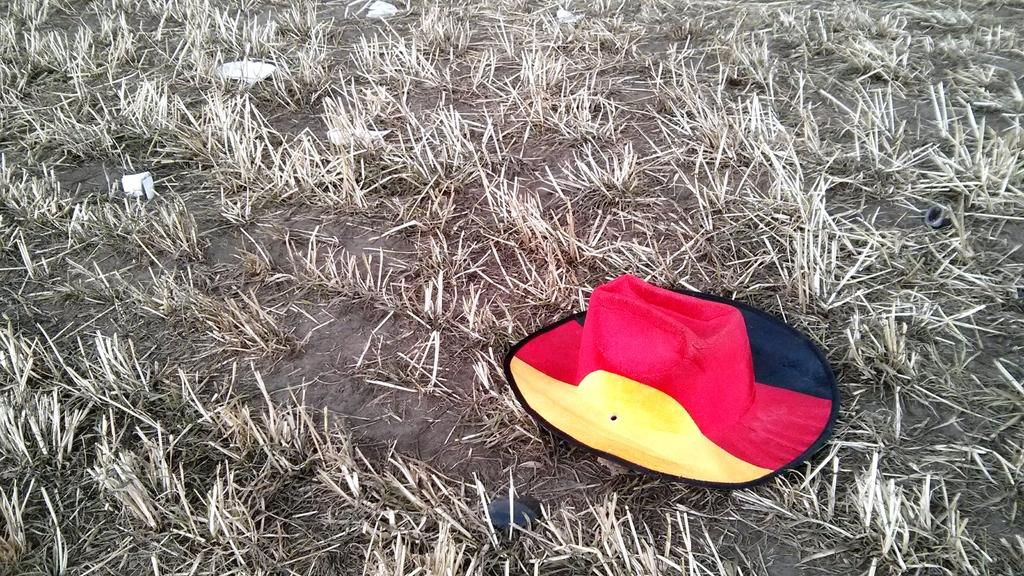What is the main subject in the center of the image? There is a hat in the center of the image. Can you describe the colors of the hat? The hat is yellow, black, and red in color. What type of natural environment can be seen in the background of the image? There is grass visible in the background of the image. Are there any other objects or features in the background of the image? Yes, there are a few other objects in the background of the image. Can you see the mother and kitty playing in the window in the image? There is no window, mother, or kitty present in the image. 